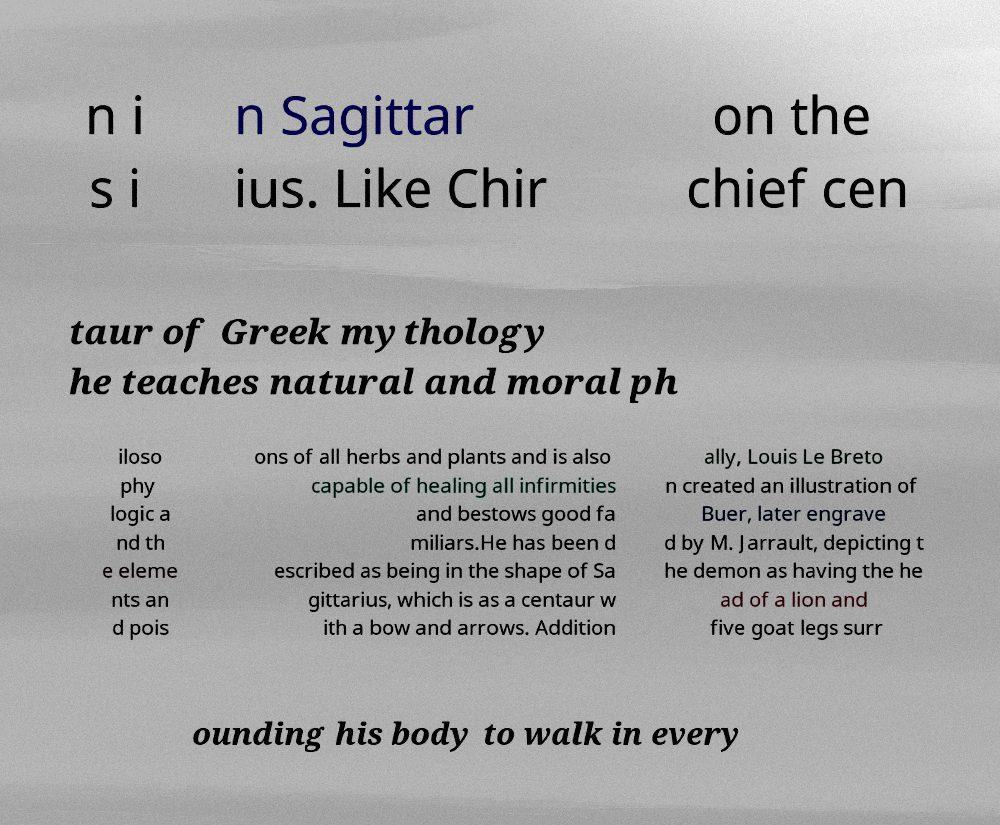What messages or text are displayed in this image? I need them in a readable, typed format. n i s i n Sagittar ius. Like Chir on the chief cen taur of Greek mythology he teaches natural and moral ph iloso phy logic a nd th e eleme nts an d pois ons of all herbs and plants and is also capable of healing all infirmities and bestows good fa miliars.He has been d escribed as being in the shape of Sa gittarius, which is as a centaur w ith a bow and arrows. Addition ally, Louis Le Breto n created an illustration of Buer, later engrave d by M. Jarrault, depicting t he demon as having the he ad of a lion and five goat legs surr ounding his body to walk in every 